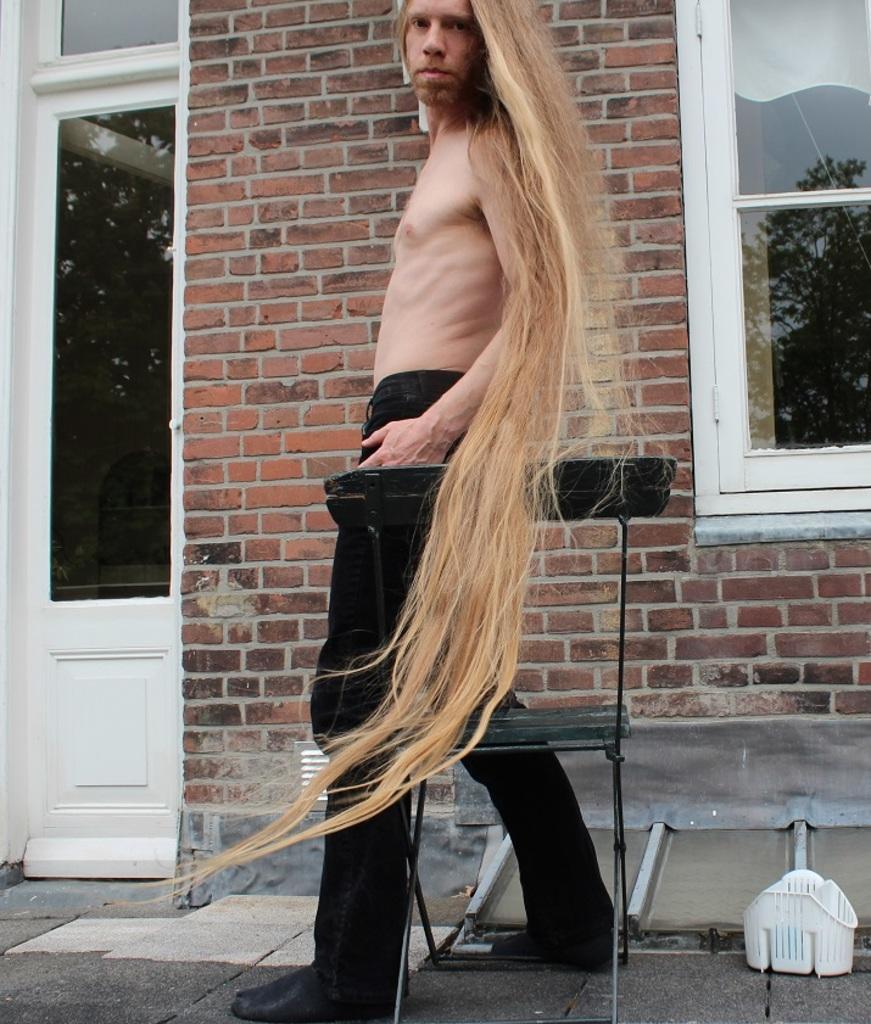Could you give a brief overview of what you see in this image? In this picture I can see a man is standing. Here I can see a chair and white color object on the ground. In the background I can see a brick wall, window and a door. 